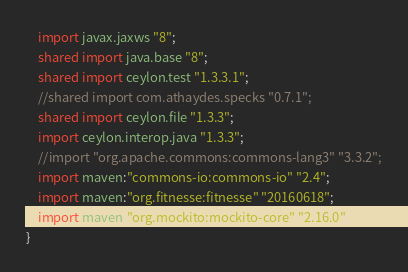<code> <loc_0><loc_0><loc_500><loc_500><_Ceylon_>	import javax.jaxws "8";
	shared import java.base "8";
	shared import ceylon.test "1.3.3.1";
	//shared import com.athaydes.specks "0.7.1";
	shared import ceylon.file "1.3.3";
	import ceylon.interop.java "1.3.3";
	//import "org.apache.commons:commons-lang3" "3.3.2";
	import maven:"commons-io:commons-io" "2.4";
	import maven:"org.fitnesse:fitnesse" "20160618";
	import maven:"org.mockito:mockito-core" "2.16.0";
}
</code> 